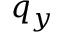<formula> <loc_0><loc_0><loc_500><loc_500>q _ { y }</formula> 